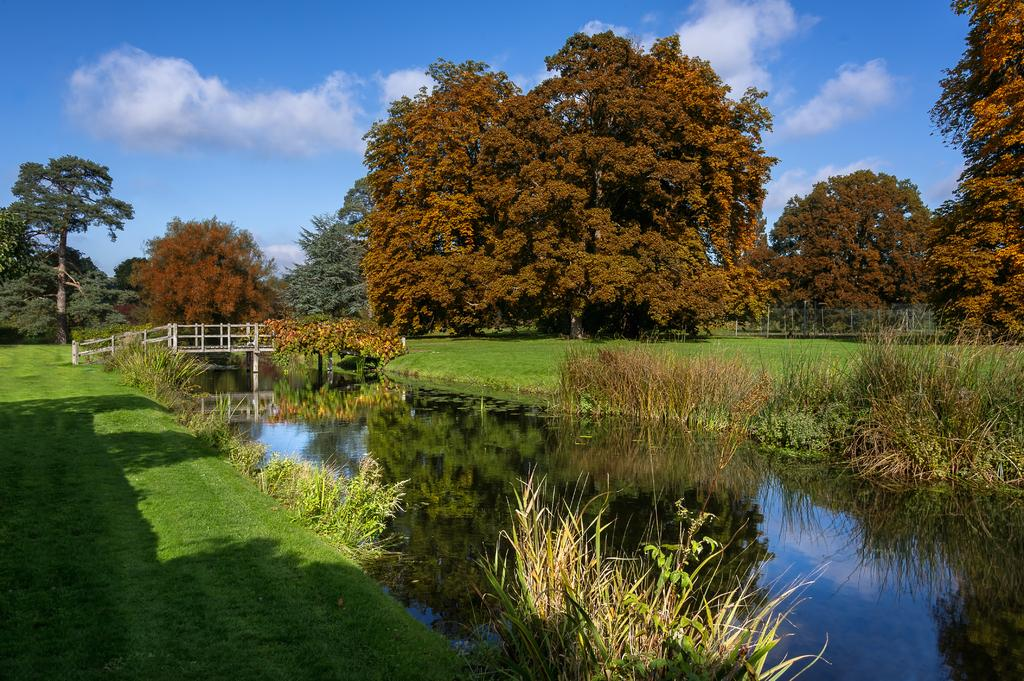What type of terrain is visible in the image? There is grass in the image. What natural feature is present in the image? There is water in the image. What structure can be seen in the image? There is a bridge in the image. What type of vegetation is present in the image? There are trees in the image. What is visible in the background of the image? The sky is visible in the image. What type of coil is used to hold the trees in the image? There is no coil present in the image; the trees are standing on their own. Can you hear the team playing in the background of the image? There is no team or any sound mentioned in the image; it only contains visual elements. 